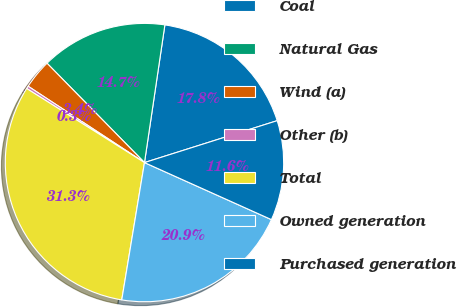Convert chart. <chart><loc_0><loc_0><loc_500><loc_500><pie_chart><fcel>Coal<fcel>Natural Gas<fcel>Wind (a)<fcel>Other (b)<fcel>Total<fcel>Owned generation<fcel>Purchased generation<nl><fcel>17.79%<fcel>14.69%<fcel>3.41%<fcel>0.31%<fcel>31.32%<fcel>20.89%<fcel>11.59%<nl></chart> 